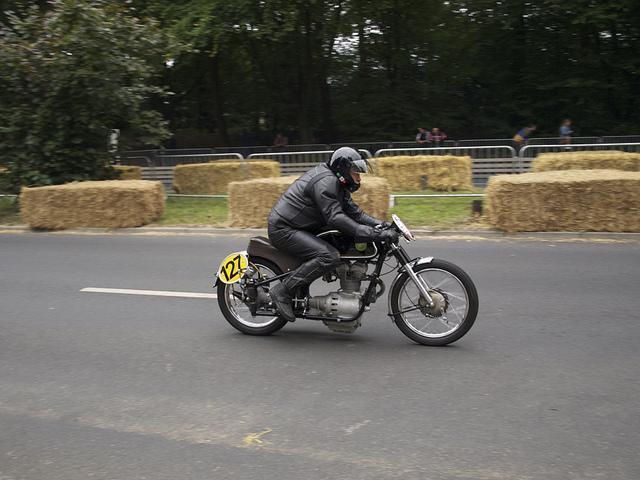How many bikes are there?
Give a very brief answer. 1. How many motorcycles are there?
Give a very brief answer. 1. 